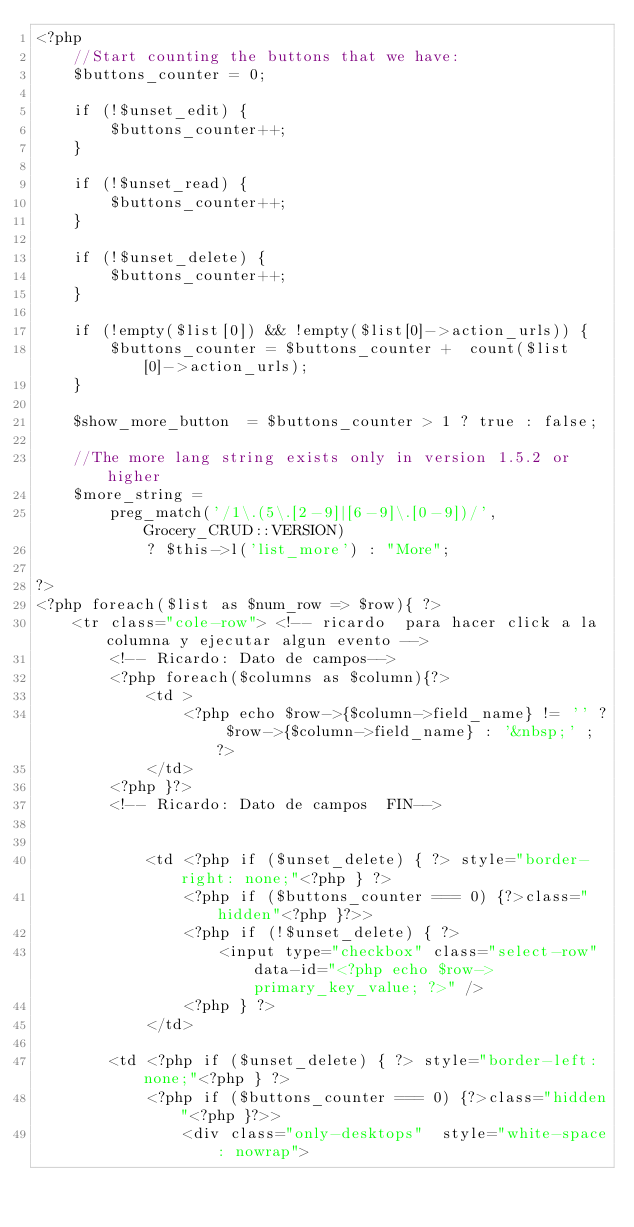<code> <loc_0><loc_0><loc_500><loc_500><_PHP_><?php
    //Start counting the buttons that we have:
    $buttons_counter = 0;

    if (!$unset_edit) {
        $buttons_counter++;
    }

    if (!$unset_read) {
        $buttons_counter++;
    }

    if (!$unset_delete) {
        $buttons_counter++;
    }

    if (!empty($list[0]) && !empty($list[0]->action_urls)) {
        $buttons_counter = $buttons_counter +  count($list[0]->action_urls);
    }

    $show_more_button  = $buttons_counter > 1 ? true : false;

    //The more lang string exists only in version 1.5.2 or higher
    $more_string =
        preg_match('/1\.(5\.[2-9]|[6-9]\.[0-9])/', Grocery_CRUD::VERSION)
            ? $this->l('list_more') : "More";

?>
<?php foreach($list as $num_row => $row){ ?>
    <tr class="cole-row"> <!-- ricardo  para hacer click a la columna y ejecutar algun evento -->
        <!-- Ricardo: Dato de campos-->
        <?php foreach($columns as $column){?>
            <td >
                <?php echo $row->{$column->field_name} != '' ? $row->{$column->field_name} : '&nbsp;' ; ?>
            </td>
        <?php }?>
        <!-- Ricardo: Dato de campos  FIN-->

      
            <td <?php if ($unset_delete) { ?> style="border-right: none;"<?php } ?>
                <?php if ($buttons_counter === 0) {?>class="hidden"<?php }?>>
                <?php if (!$unset_delete) { ?>
                    <input type="checkbox" class="select-row" data-id="<?php echo $row->primary_key_value; ?>" />
                <?php } ?>
            </td>
       
        <td <?php if ($unset_delete) { ?> style="border-left: none;"<?php } ?>
            <?php if ($buttons_counter === 0) {?>class="hidden"<?php }?>>
                <div class="only-desktops"  style="white-space: nowrap">
</code> 